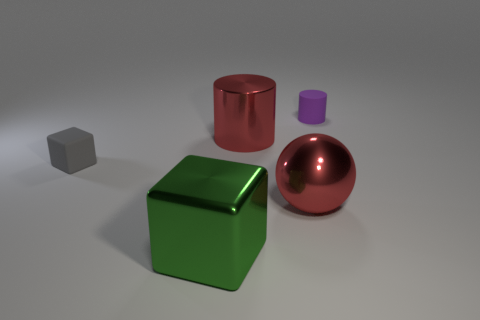Subtract all spheres. How many objects are left? 4 Subtract 1 spheres. How many spheres are left? 0 Subtract all brown blocks. Subtract all gray cylinders. How many blocks are left? 2 Subtract all yellow cubes. How many red cylinders are left? 1 Subtract all large metallic spheres. Subtract all small things. How many objects are left? 2 Add 1 green cubes. How many green cubes are left? 2 Add 5 rubber cylinders. How many rubber cylinders exist? 6 Add 1 big balls. How many objects exist? 6 Subtract all purple cylinders. How many cylinders are left? 1 Subtract 0 blue cubes. How many objects are left? 5 